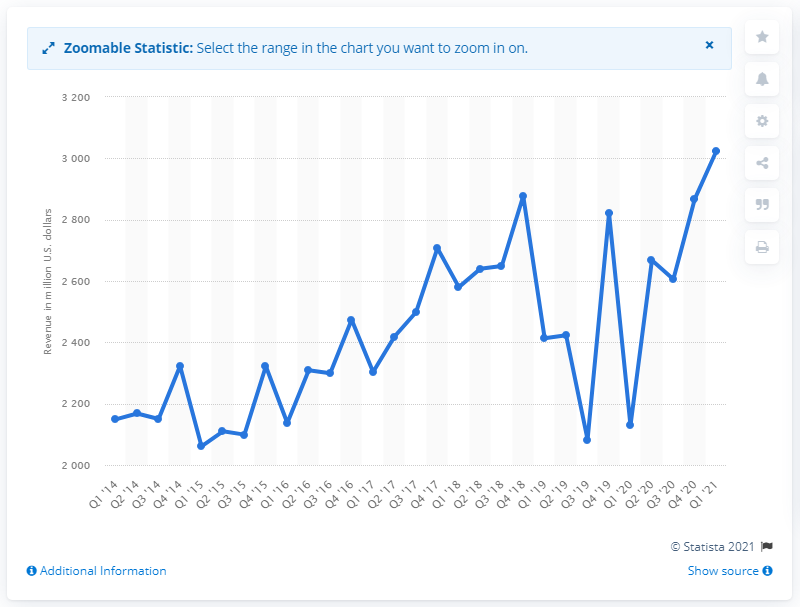Mention a couple of crucial points in this snapshot. In the most recent quarter, approximately 27% of eBay's total revenue was generated through transactions. 